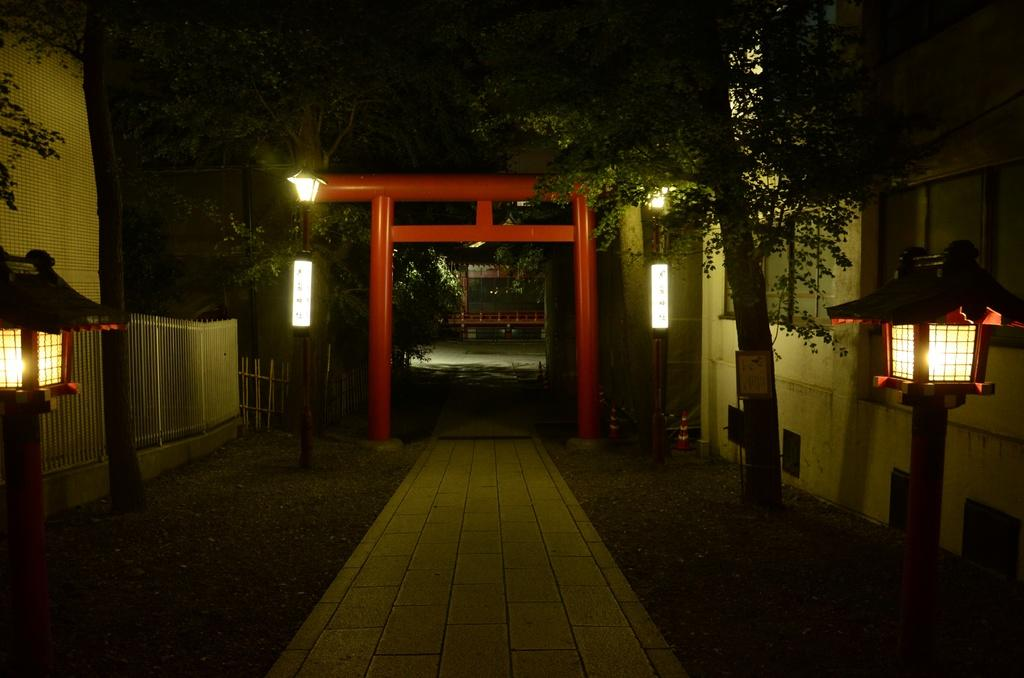What type of structure can be seen in the image? There is an arch in the image. What can be found beneath the arch? There is a path in the image. What provides illumination along the path? Light poles are visible in the image. What type of vegetation is present in the image? There are trees in the image. What separates the area from its surroundings? There is a fence in the image. What might be used to direct traffic or indicate a construction area? Traffic cones are present in the image. What type of man-made structures can be seen in the image? There are buildings in the image. What architectural features can be seen on the buildings? Windows are visible in the image. Are there any unidentified objects in the image? Yes, there are some unspecified objects in the image. How does the calendar help to organize the events in the image? There is no calendar present in the image; it only features an arch, path, light poles, trees, fence, traffic cones, buildings, windows, and unspecified objects. 